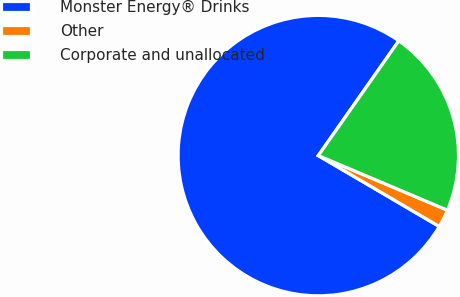Convert chart. <chart><loc_0><loc_0><loc_500><loc_500><pie_chart><fcel>Monster Energy® Drinks<fcel>Other<fcel>Corporate and unallocated<nl><fcel>76.3%<fcel>2.07%<fcel>21.63%<nl></chart> 